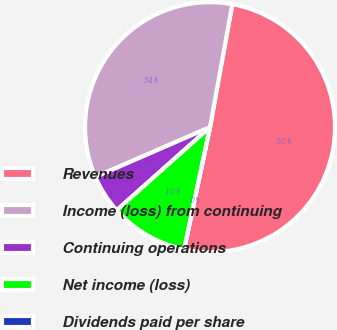Convert chart to OTSL. <chart><loc_0><loc_0><loc_500><loc_500><pie_chart><fcel>Revenues<fcel>Income (loss) from continuing<fcel>Continuing operations<fcel>Net income (loss)<fcel>Dividends paid per share<nl><fcel>50.47%<fcel>34.38%<fcel>5.05%<fcel>10.1%<fcel>0.0%<nl></chart> 